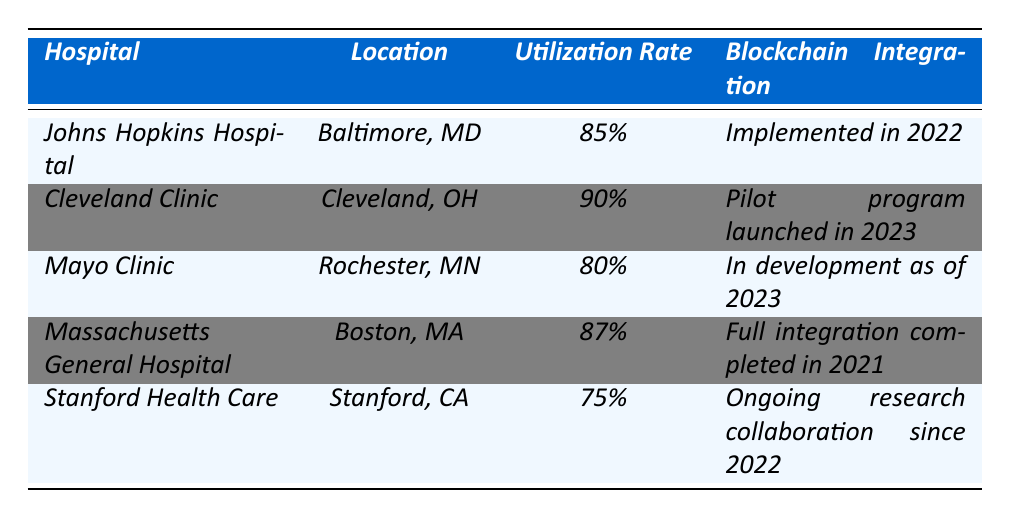What is the hospital with the highest utilization rate? By examining the utilization rates listed in the table, Cleveland Clinic has the highest rate at 90%.
Answer: Cleveland Clinic What is the location of Massachusetts General Hospital? The table lists Boston, MA as the location of Massachusetts General Hospital.
Answer: Boston, MA How many hospitals have a utilization rate above 80%? The hospitals with utilization rates above 80% are Cleveland Clinic (90%), Massachusetts General Hospital (87%), and Johns Hopkins Hospital (85%). That makes a total of three hospitals.
Answer: 3 What is the blockchain integration status of Stanford Health Care? According to the table, Stanford Health Care is engaged in ongoing research collaboration since 2022 for blockchain integration.
Answer: Ongoing research collaboration since 2022 Is Mayo Clinic fully integrated with blockchain technology? The table indicates that Mayo Clinic's blockchain integration is still in development as of 2023, meaning it is not fully integrated.
Answer: No Which hospital has the lowest utilization rate? By comparing the utilization rates, Stanford Health Care holds the lowest rate at 75%.
Answer: Stanford Health Care What data privacy enhancement does Cleveland Clinic use? The table shows that Cleveland Clinic employs immutable audit trails, smart contracts for consent management, and anonymization of sensitive data as data privacy enhancements.
Answer: Immutable audit trails What is the average utilization rate of all listed hospitals? To find the average, we add the utilization rates: 85 + 90 + 80 + 87 + 75 = 417 and divide by 5 hospitals, so 417 / 5 = 83.4%.
Answer: 83.4% Are there any hospitals that have completed full integration of blockchain as of 2023? The table states that Massachusetts General Hospital has completed full integration in 2021, while others either have pilot programs or are in development, confirming that at least one has completed full integration.
Answer: Yes Which hospital has implemented blockchain the earliest based on the table? Looking at the blockchain integration dates, Johns Hopkins Hospital implemented it in 2022, while Massachusetts General Hospital completed full integration in 2021, making the latter the earliest.
Answer: Massachusetts General Hospital 